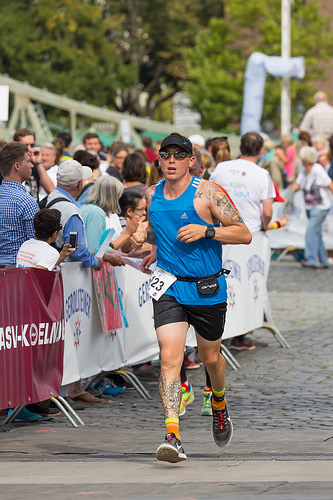<image>
Is the fence behind the man? Yes. From this viewpoint, the fence is positioned behind the man, with the man partially or fully occluding the fence. 